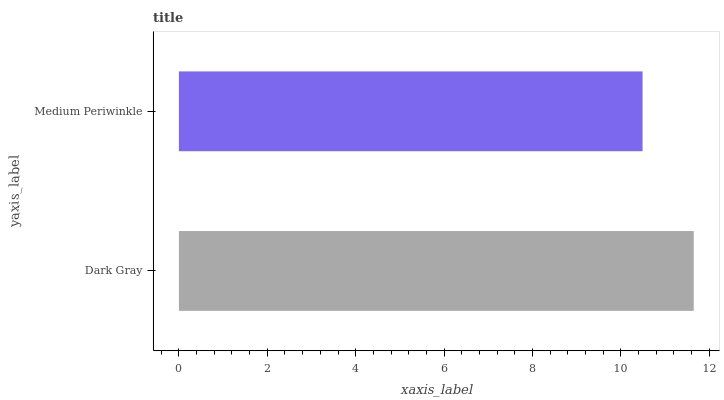Is Medium Periwinkle the minimum?
Answer yes or no. Yes. Is Dark Gray the maximum?
Answer yes or no. Yes. Is Medium Periwinkle the maximum?
Answer yes or no. No. Is Dark Gray greater than Medium Periwinkle?
Answer yes or no. Yes. Is Medium Periwinkle less than Dark Gray?
Answer yes or no. Yes. Is Medium Periwinkle greater than Dark Gray?
Answer yes or no. No. Is Dark Gray less than Medium Periwinkle?
Answer yes or no. No. Is Dark Gray the high median?
Answer yes or no. Yes. Is Medium Periwinkle the low median?
Answer yes or no. Yes. Is Medium Periwinkle the high median?
Answer yes or no. No. Is Dark Gray the low median?
Answer yes or no. No. 